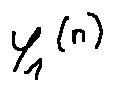<formula> <loc_0><loc_0><loc_500><loc_500>Y _ { 1 } ^ { ( n ) }</formula> 